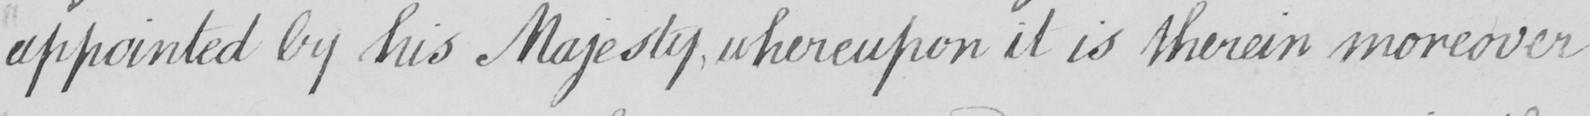Can you tell me what this handwritten text says? appointed by his Majesty whereupon it is therein moreover 